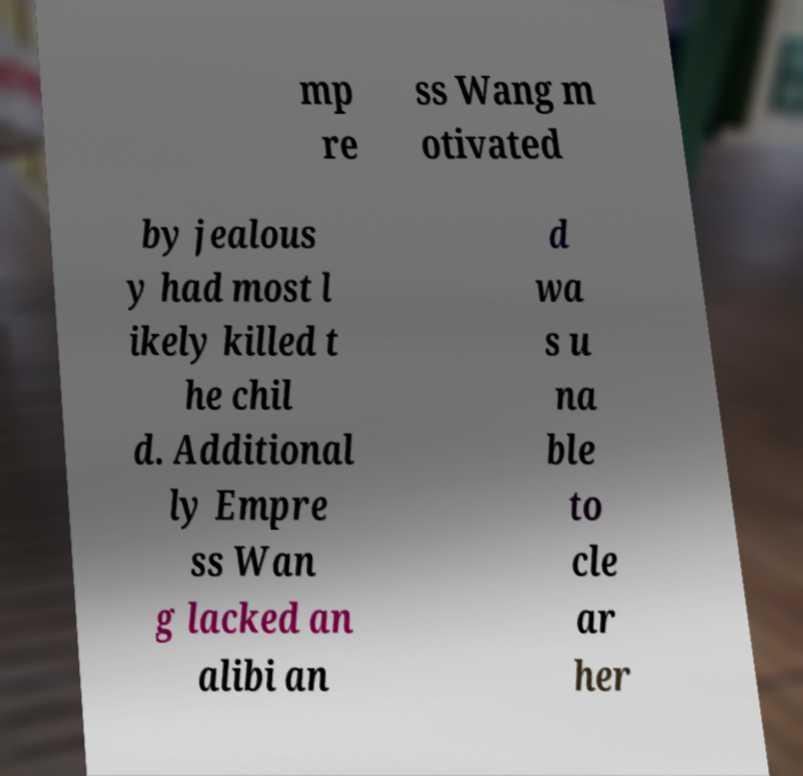For documentation purposes, I need the text within this image transcribed. Could you provide that? mp re ss Wang m otivated by jealous y had most l ikely killed t he chil d. Additional ly Empre ss Wan g lacked an alibi an d wa s u na ble to cle ar her 